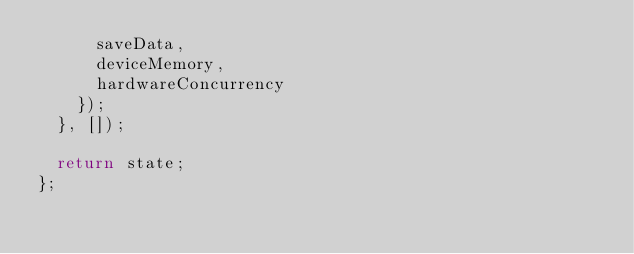<code> <loc_0><loc_0><loc_500><loc_500><_TypeScript_>      saveData,
      deviceMemory,
      hardwareConcurrency
    });
  }, []);

  return state;
};
</code> 